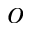<formula> <loc_0><loc_0><loc_500><loc_500>o</formula> 